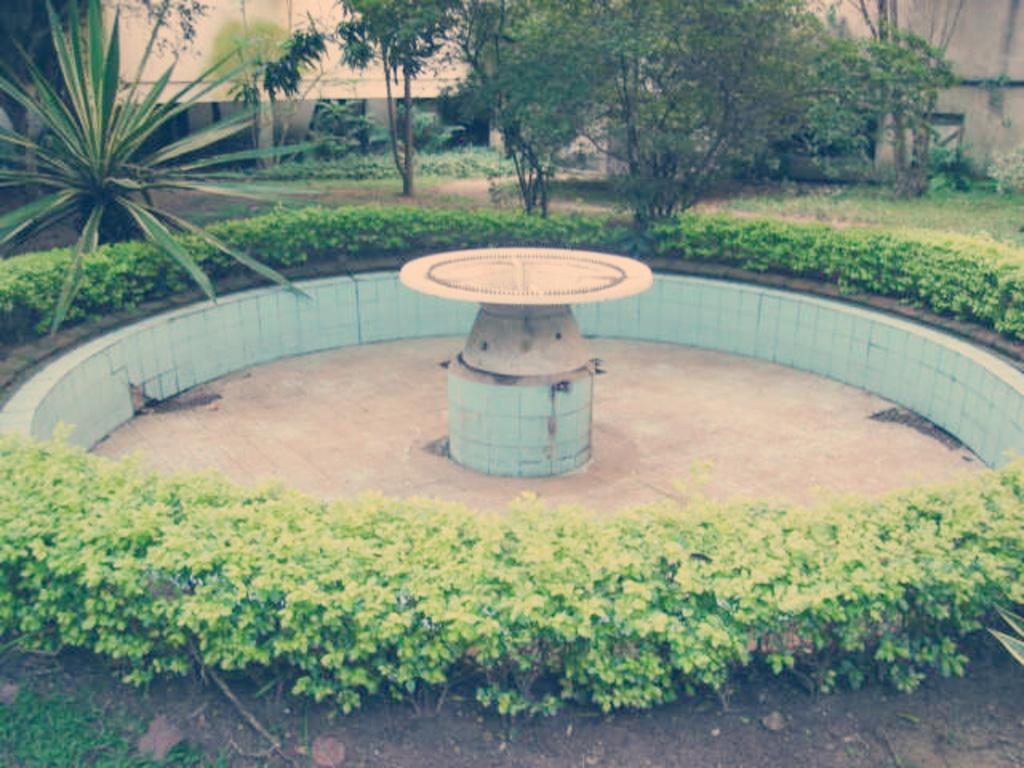What type of location is depicted in the image? The location appears to be a garden. What can be found in the center of the garden? There is a fountain in the center of the garden. What type of vegetation is present around the fountain? There are plants around the fountain. What can be seen in the background of the image? There are trees and a building in the background. What type of crime is being committed in the image? There is no crime being committed in the image; it depicts a peaceful garden scene. What point is being made by the presence of the building in the background? The presence of the building in the background does not make a specific point; it simply provides context for the garden's location. 